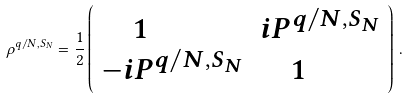Convert formula to latex. <formula><loc_0><loc_0><loc_500><loc_500>\rho ^ { q / N , S _ { N } } = { \frac { 1 } { 2 } } \left ( \begin{array} { l l } { \quad 1 } & { { i P ^ { q / N , S _ { N } } } } \\ { { - i P ^ { q / N , S _ { N } } } } & { \quad 1 } \end{array} \right ) \, .</formula> 